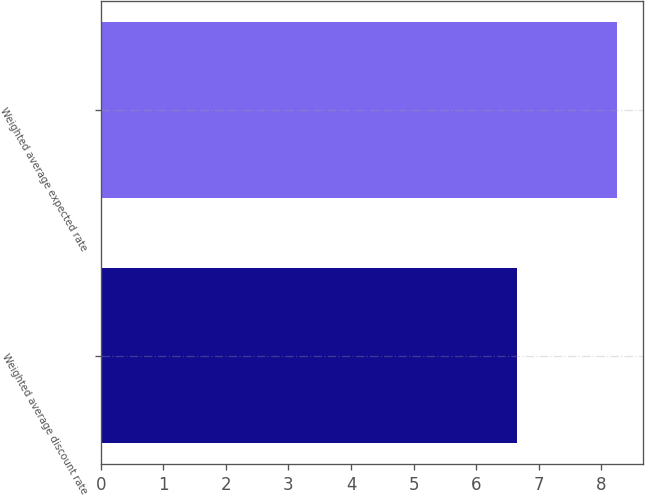<chart> <loc_0><loc_0><loc_500><loc_500><bar_chart><fcel>Weighted average discount rate<fcel>Weighted average expected rate<nl><fcel>6.65<fcel>8.25<nl></chart> 